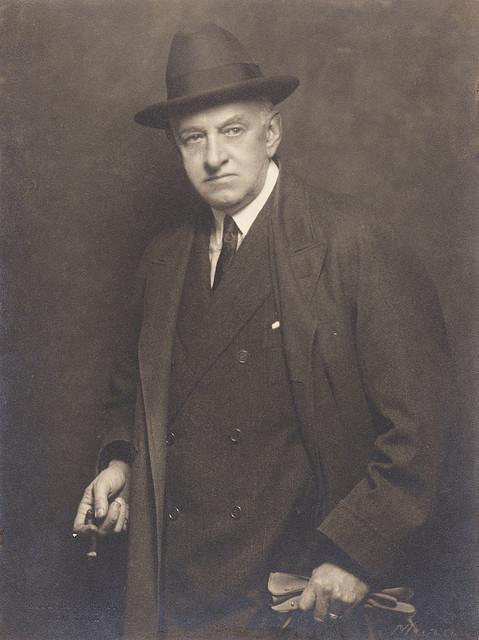Is the man's real nose visible in the photo?
Give a very brief answer. Yes. What is the person looking at?
Keep it brief. Camera. What type of hat is being worn?
Give a very brief answer. Fedora. Does this man have facial hair?
Quick response, please. No. Is the person in a competition?
Quick response, please. No. What is he holding in his hand?
Write a very short answer. Gloves. How many people are in the photo?
Be succinct. 1. What kind of glasses is he wearing?
Answer briefly. None. Is there a skateboard in this picture?
Write a very short answer. No. Do you think this man was a smoker?
Be succinct. Yes. How old is the man?
Quick response, please. 78. What is in the man's hand?
Answer briefly. Cigar. Has the man shaved today?
Concise answer only. Yes. Is the man real?
Give a very brief answer. Yes. Is the man cool?
Keep it brief. Yes. Is this a contemporary photo?
Quick response, please. No. How many thumbs are showing?
Keep it brief. 1. Do you think this picture was posted?
Be succinct. No. What is the man holding?
Be succinct. Cigar. What does the man have on his head?
Give a very brief answer. Hat. Is he having fun?
Quick response, please. No. When was the photo taken?
Give a very brief answer. Long time ago. Does this man look happy?
Answer briefly. No. What kind of hat is this?
Answer briefly. Fedora. 